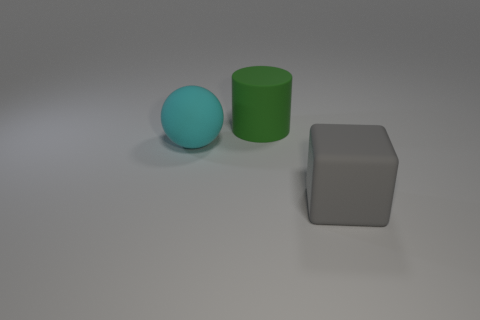Add 2 big cyan rubber balls. How many objects exist? 5 Subtract all cylinders. How many objects are left? 2 Add 1 big green cylinders. How many big green cylinders are left? 2 Add 3 blue cylinders. How many blue cylinders exist? 3 Subtract 0 red spheres. How many objects are left? 3 Subtract all gray cubes. Subtract all cubes. How many objects are left? 1 